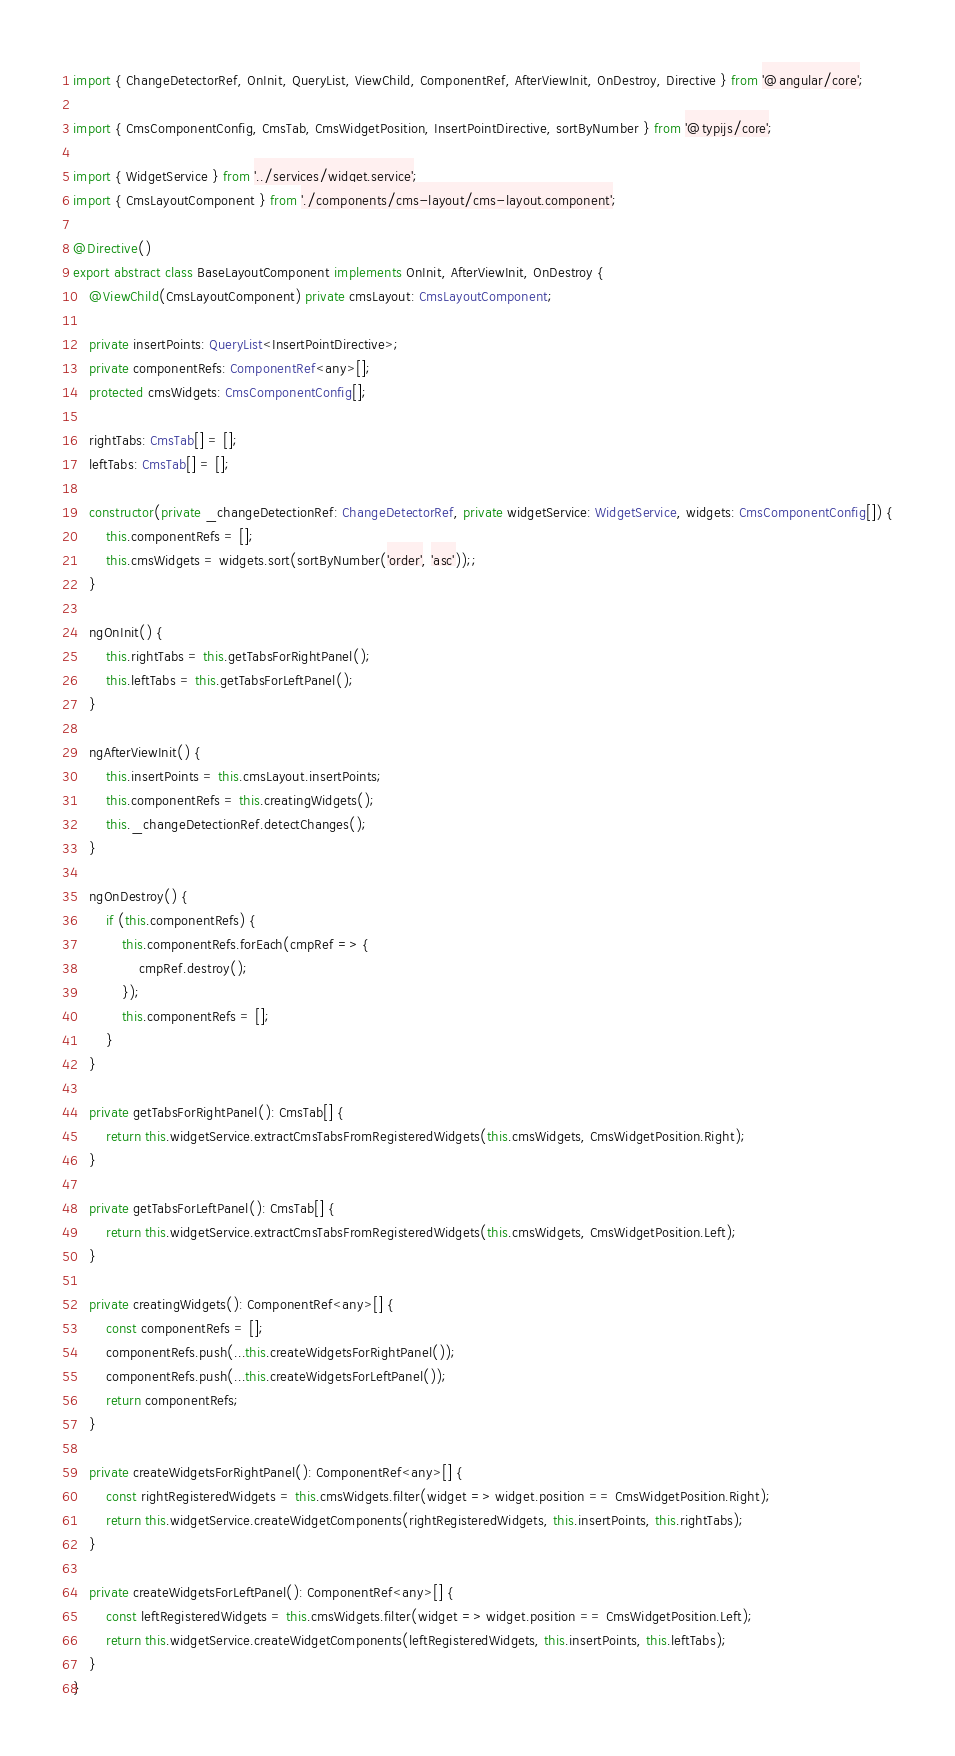Convert code to text. <code><loc_0><loc_0><loc_500><loc_500><_TypeScript_>import { ChangeDetectorRef, OnInit, QueryList, ViewChild, ComponentRef, AfterViewInit, OnDestroy, Directive } from '@angular/core';

import { CmsComponentConfig, CmsTab, CmsWidgetPosition, InsertPointDirective, sortByNumber } from '@typijs/core';

import { WidgetService } from '../services/widget.service';
import { CmsLayoutComponent } from './components/cms-layout/cms-layout.component';

@Directive()
export abstract class BaseLayoutComponent implements OnInit, AfterViewInit, OnDestroy {
    @ViewChild(CmsLayoutComponent) private cmsLayout: CmsLayoutComponent;

    private insertPoints: QueryList<InsertPointDirective>;
    private componentRefs: ComponentRef<any>[];
    protected cmsWidgets: CmsComponentConfig[];

    rightTabs: CmsTab[] = [];
    leftTabs: CmsTab[] = [];

    constructor(private _changeDetectionRef: ChangeDetectorRef, private widgetService: WidgetService, widgets: CmsComponentConfig[]) {
        this.componentRefs = [];
        this.cmsWidgets = widgets.sort(sortByNumber('order', 'asc'));;
    }

    ngOnInit() {
        this.rightTabs = this.getTabsForRightPanel();
        this.leftTabs = this.getTabsForLeftPanel();
    }

    ngAfterViewInit() {
        this.insertPoints = this.cmsLayout.insertPoints;
        this.componentRefs = this.creatingWidgets();
        this._changeDetectionRef.detectChanges();
    }

    ngOnDestroy() {
        if (this.componentRefs) {
            this.componentRefs.forEach(cmpRef => {
                cmpRef.destroy();
            });
            this.componentRefs = [];
        }
    }

    private getTabsForRightPanel(): CmsTab[] {
        return this.widgetService.extractCmsTabsFromRegisteredWidgets(this.cmsWidgets, CmsWidgetPosition.Right);
    }

    private getTabsForLeftPanel(): CmsTab[] {
        return this.widgetService.extractCmsTabsFromRegisteredWidgets(this.cmsWidgets, CmsWidgetPosition.Left);
    }

    private creatingWidgets(): ComponentRef<any>[] {
        const componentRefs = [];
        componentRefs.push(...this.createWidgetsForRightPanel());
        componentRefs.push(...this.createWidgetsForLeftPanel());
        return componentRefs;
    }

    private createWidgetsForRightPanel(): ComponentRef<any>[] {
        const rightRegisteredWidgets = this.cmsWidgets.filter(widget => widget.position == CmsWidgetPosition.Right);
        return this.widgetService.createWidgetComponents(rightRegisteredWidgets, this.insertPoints, this.rightTabs);
    }

    private createWidgetsForLeftPanel(): ComponentRef<any>[] {
        const leftRegisteredWidgets = this.cmsWidgets.filter(widget => widget.position == CmsWidgetPosition.Left);
        return this.widgetService.createWidgetComponents(leftRegisteredWidgets, this.insertPoints, this.leftTabs);
    }
}
</code> 